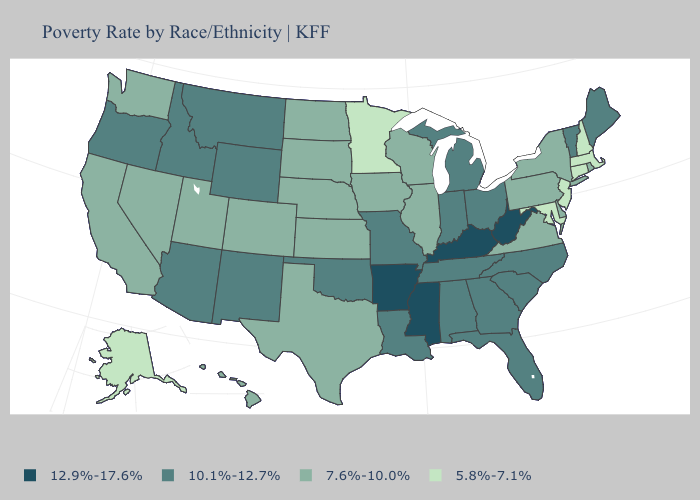Name the states that have a value in the range 7.6%-10.0%?
Answer briefly. California, Colorado, Delaware, Hawaii, Illinois, Iowa, Kansas, Nebraska, Nevada, New York, North Dakota, Pennsylvania, Rhode Island, South Dakota, Texas, Utah, Virginia, Washington, Wisconsin. What is the lowest value in the South?
Answer briefly. 5.8%-7.1%. What is the highest value in the West ?
Concise answer only. 10.1%-12.7%. What is the lowest value in the USA?
Keep it brief. 5.8%-7.1%. Name the states that have a value in the range 10.1%-12.7%?
Quick response, please. Alabama, Arizona, Florida, Georgia, Idaho, Indiana, Louisiana, Maine, Michigan, Missouri, Montana, New Mexico, North Carolina, Ohio, Oklahoma, Oregon, South Carolina, Tennessee, Vermont, Wyoming. What is the value of North Carolina?
Quick response, please. 10.1%-12.7%. What is the highest value in the Northeast ?
Write a very short answer. 10.1%-12.7%. What is the value of Indiana?
Quick response, please. 10.1%-12.7%. What is the value of Idaho?
Give a very brief answer. 10.1%-12.7%. What is the lowest value in the USA?
Answer briefly. 5.8%-7.1%. Name the states that have a value in the range 5.8%-7.1%?
Give a very brief answer. Alaska, Connecticut, Maryland, Massachusetts, Minnesota, New Hampshire, New Jersey. What is the value of Kentucky?
Keep it brief. 12.9%-17.6%. What is the value of South Dakota?
Short answer required. 7.6%-10.0%. What is the value of New Jersey?
Concise answer only. 5.8%-7.1%. 